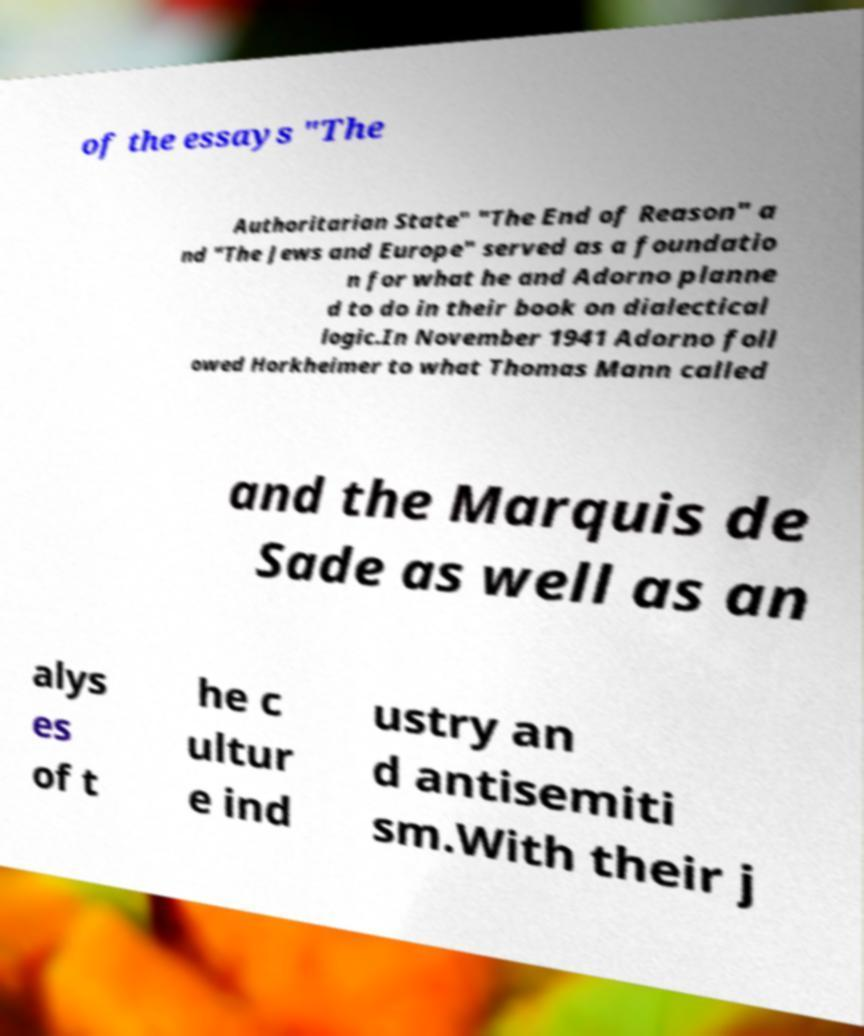For documentation purposes, I need the text within this image transcribed. Could you provide that? of the essays "The Authoritarian State" "The End of Reason" a nd "The Jews and Europe" served as a foundatio n for what he and Adorno planne d to do in their book on dialectical logic.In November 1941 Adorno foll owed Horkheimer to what Thomas Mann called and the Marquis de Sade as well as an alys es of t he c ultur e ind ustry an d antisemiti sm.With their j 